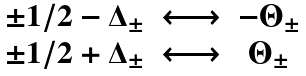Convert formula to latex. <formula><loc_0><loc_0><loc_500><loc_500>\begin{array} { c c c } \pm 1 / 2 - \Delta _ { \pm } & \longleftrightarrow & - \Theta _ { \pm } \\ \pm 1 / 2 + \Delta _ { \pm } & \longleftrightarrow & \Theta _ { \pm } \end{array}</formula> 